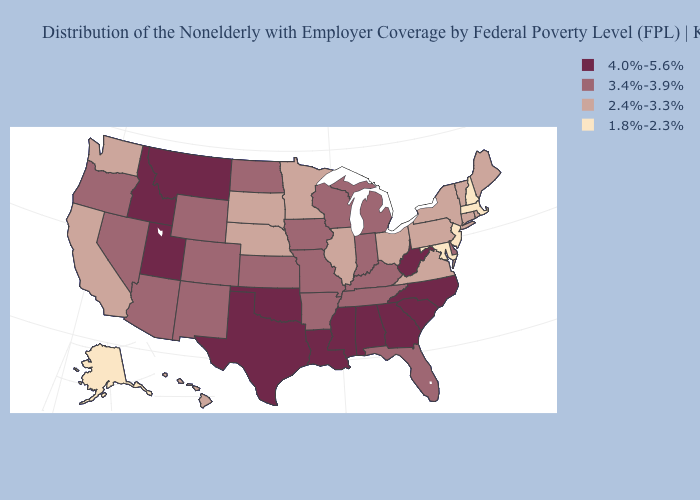How many symbols are there in the legend?
Write a very short answer. 4. Name the states that have a value in the range 2.4%-3.3%?
Short answer required. California, Connecticut, Hawaii, Illinois, Maine, Minnesota, Nebraska, New York, Ohio, Pennsylvania, Rhode Island, South Dakota, Vermont, Virginia, Washington. What is the highest value in states that border North Dakota?
Quick response, please. 4.0%-5.6%. Does Colorado have a higher value than California?
Be succinct. Yes. Does the map have missing data?
Be succinct. No. What is the lowest value in the USA?
Be succinct. 1.8%-2.3%. Does Massachusetts have a lower value than Tennessee?
Give a very brief answer. Yes. Name the states that have a value in the range 2.4%-3.3%?
Keep it brief. California, Connecticut, Hawaii, Illinois, Maine, Minnesota, Nebraska, New York, Ohio, Pennsylvania, Rhode Island, South Dakota, Vermont, Virginia, Washington. Name the states that have a value in the range 4.0%-5.6%?
Short answer required. Alabama, Georgia, Idaho, Louisiana, Mississippi, Montana, North Carolina, Oklahoma, South Carolina, Texas, Utah, West Virginia. Which states have the lowest value in the Northeast?
Answer briefly. Massachusetts, New Hampshire, New Jersey. Name the states that have a value in the range 3.4%-3.9%?
Short answer required. Arizona, Arkansas, Colorado, Delaware, Florida, Indiana, Iowa, Kansas, Kentucky, Michigan, Missouri, Nevada, New Mexico, North Dakota, Oregon, Tennessee, Wisconsin, Wyoming. Name the states that have a value in the range 1.8%-2.3%?
Quick response, please. Alaska, Maryland, Massachusetts, New Hampshire, New Jersey. What is the value of Colorado?
Short answer required. 3.4%-3.9%. What is the value of Missouri?
Give a very brief answer. 3.4%-3.9%. What is the lowest value in states that border North Carolina?
Keep it brief. 2.4%-3.3%. 